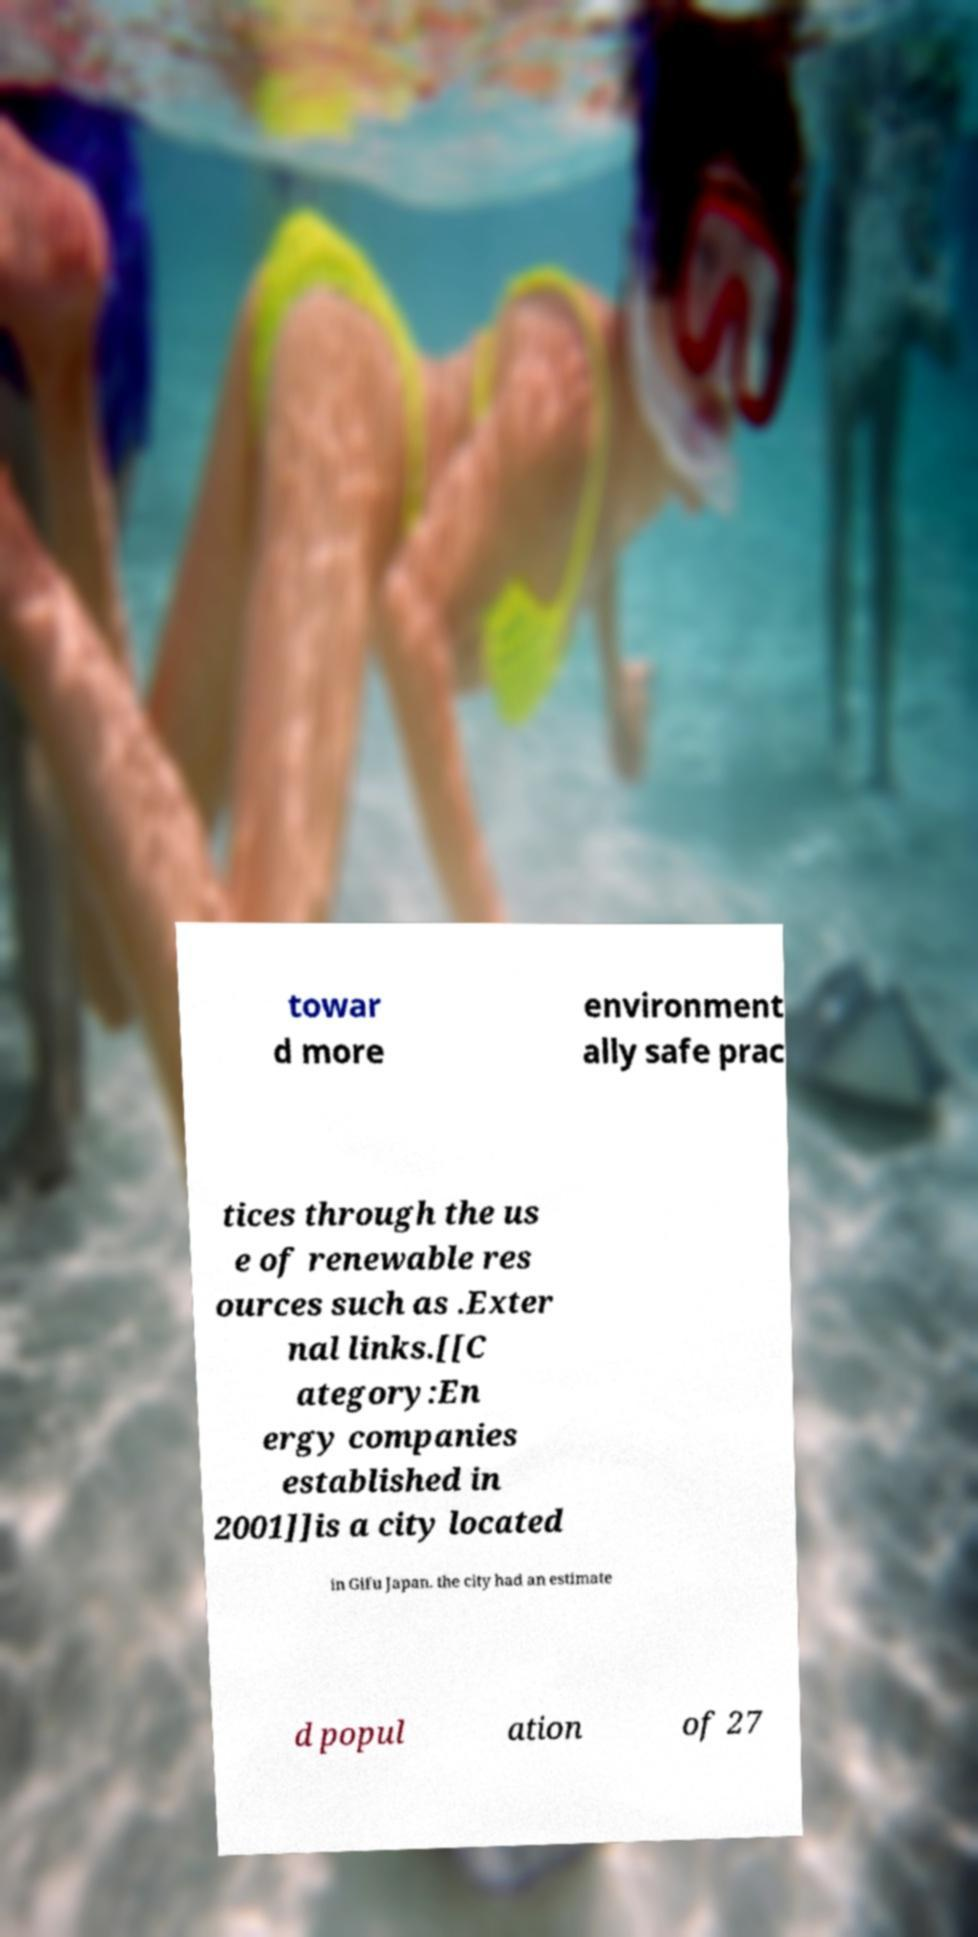Can you read and provide the text displayed in the image?This photo seems to have some interesting text. Can you extract and type it out for me? towar d more environment ally safe prac tices through the us e of renewable res ources such as .Exter nal links.[[C ategory:En ergy companies established in 2001]]is a city located in Gifu Japan. the city had an estimate d popul ation of 27 